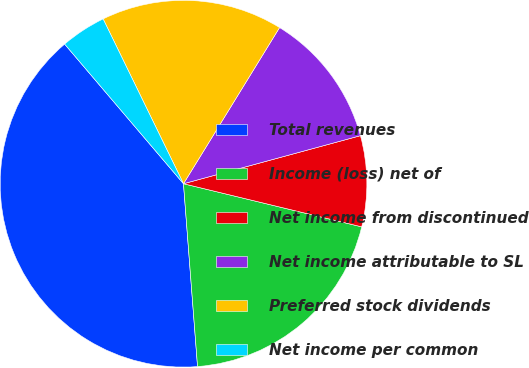Convert chart to OTSL. <chart><loc_0><loc_0><loc_500><loc_500><pie_chart><fcel>Total revenues<fcel>Income (loss) net of<fcel>Net income from discontinued<fcel>Net income attributable to SL<fcel>Preferred stock dividends<fcel>Net income per common<nl><fcel>40.0%<fcel>20.0%<fcel>8.0%<fcel>12.0%<fcel>16.0%<fcel>4.0%<nl></chart> 